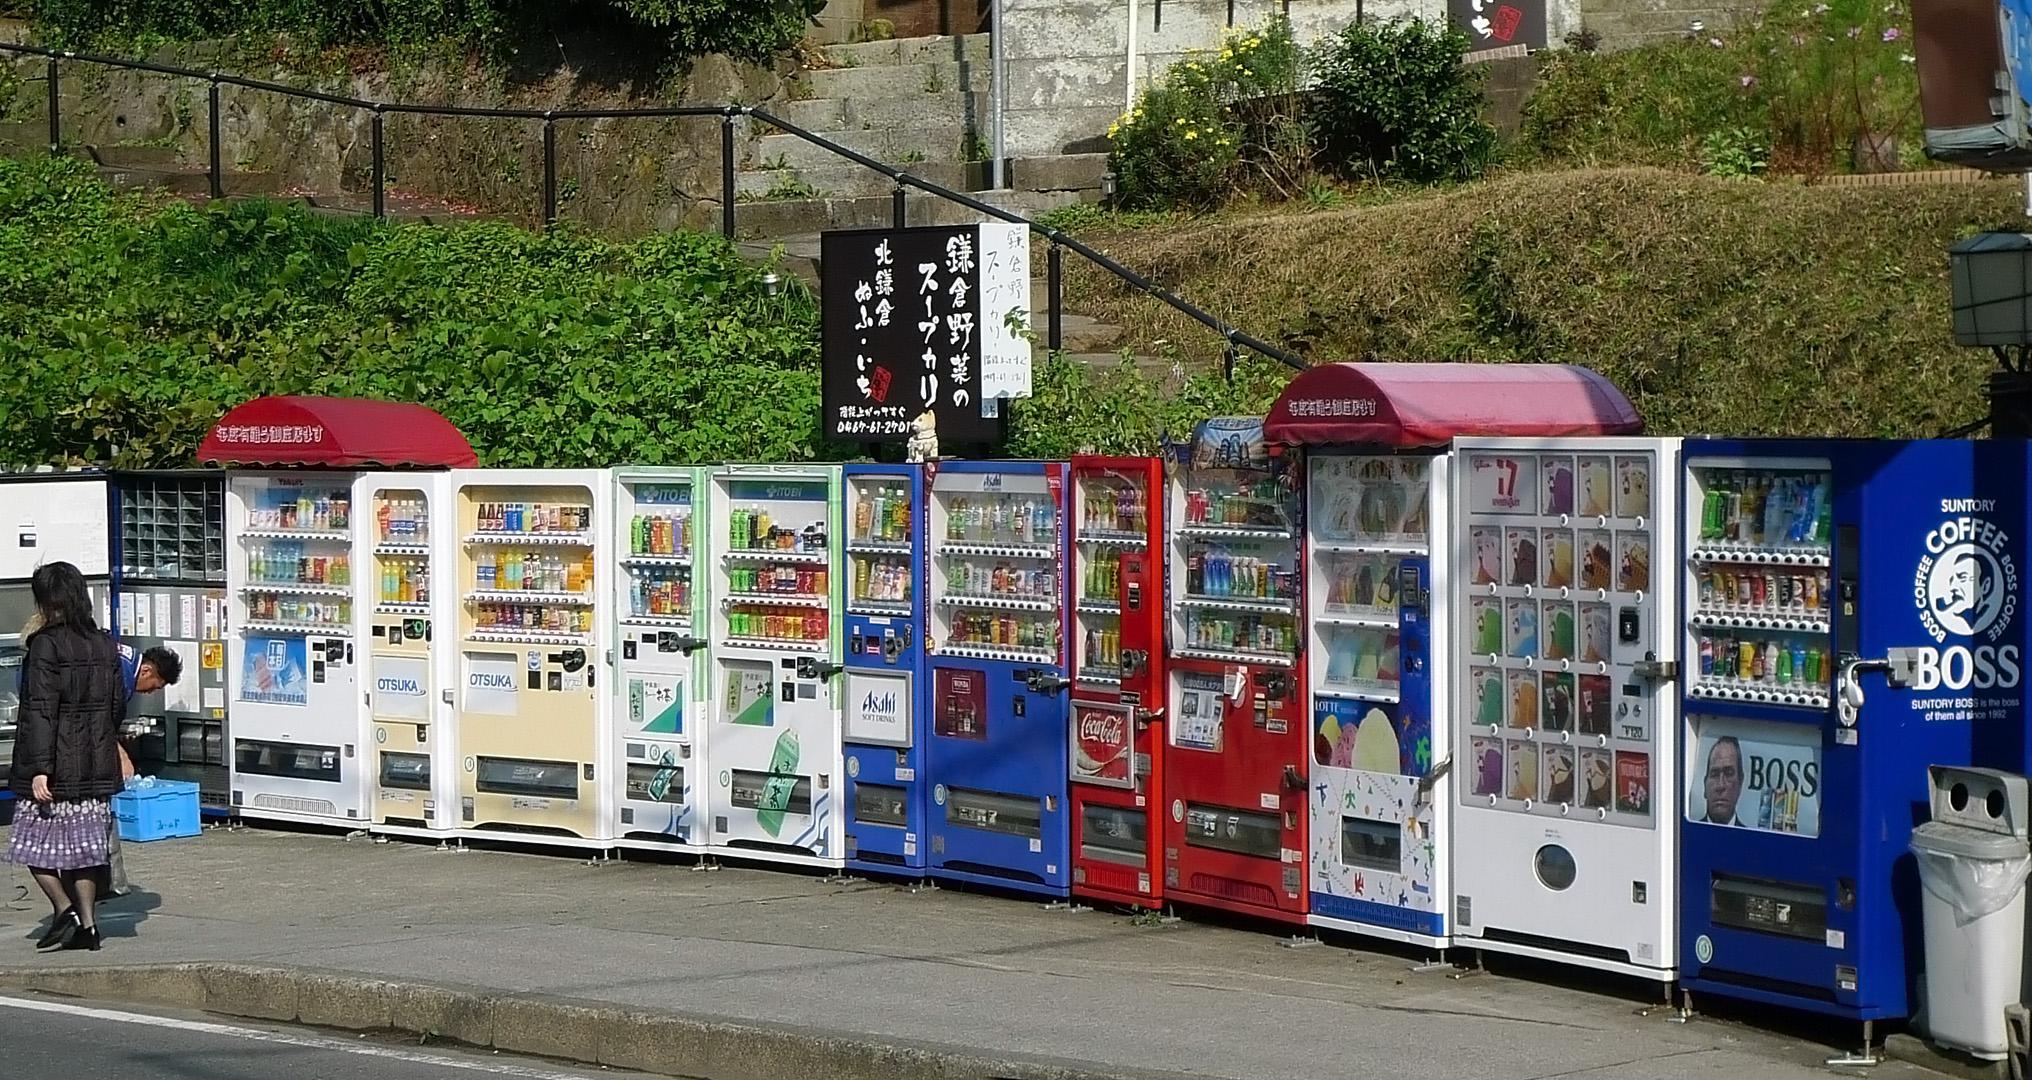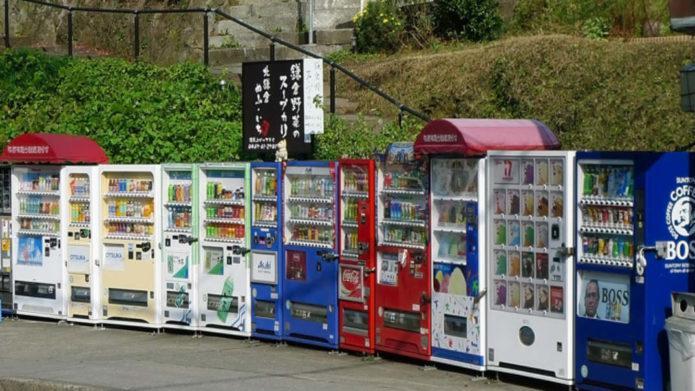The first image is the image on the left, the second image is the image on the right. Examine the images to the left and right. Is the description "There is at least one person standing outside near the machines in the image on the right." accurate? Answer yes or no. No. The first image is the image on the left, the second image is the image on the right. Examine the images to the left and right. Is the description "A standing person is visible only at the far end of a long row of vending machines." accurate? Answer yes or no. Yes. 